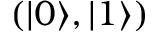<formula> <loc_0><loc_0><loc_500><loc_500>( | 0 \rangle , | 1 \rangle )</formula> 